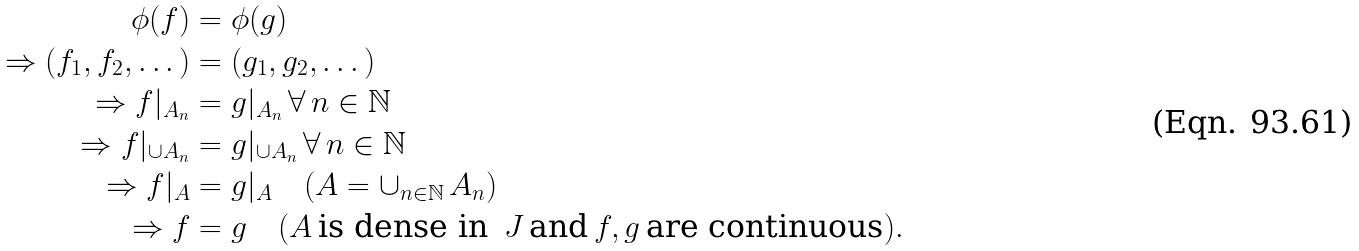Convert formula to latex. <formula><loc_0><loc_0><loc_500><loc_500>\phi ( f ) & = \phi ( g ) \\ \Rightarrow ( f _ { 1 } , f _ { 2 } , \dots ) & = ( g _ { 1 } , g _ { 2 } , \dots ) \\ \Rightarrow f | _ { A _ { n } } & = g | _ { A _ { n } } \, \forall \, n \in \mathbb { N } \\ \Rightarrow f | _ { \cup A _ { n } } & = g | _ { \cup A _ { n } } \, \forall \, n \in \mathbb { N } \\ \Rightarrow f | _ { A } & = g | _ { A } \quad ( A = \cup _ { n \in \mathbb { N } } \, A _ { n } ) \\ \Rightarrow f & = g \quad ( A \, \text {is dense in} \, \ J \, \text {and} \, f , g \, \text {are continuous} ) .</formula> 